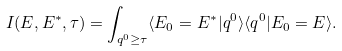Convert formula to latex. <formula><loc_0><loc_0><loc_500><loc_500>I ( E , E ^ { * } , \tau ) = \int _ { q ^ { 0 } \geq \tau } \langle E _ { 0 } = E ^ { * } | q ^ { 0 } \rangle \langle q ^ { 0 } | E _ { 0 } = E \rangle .</formula> 